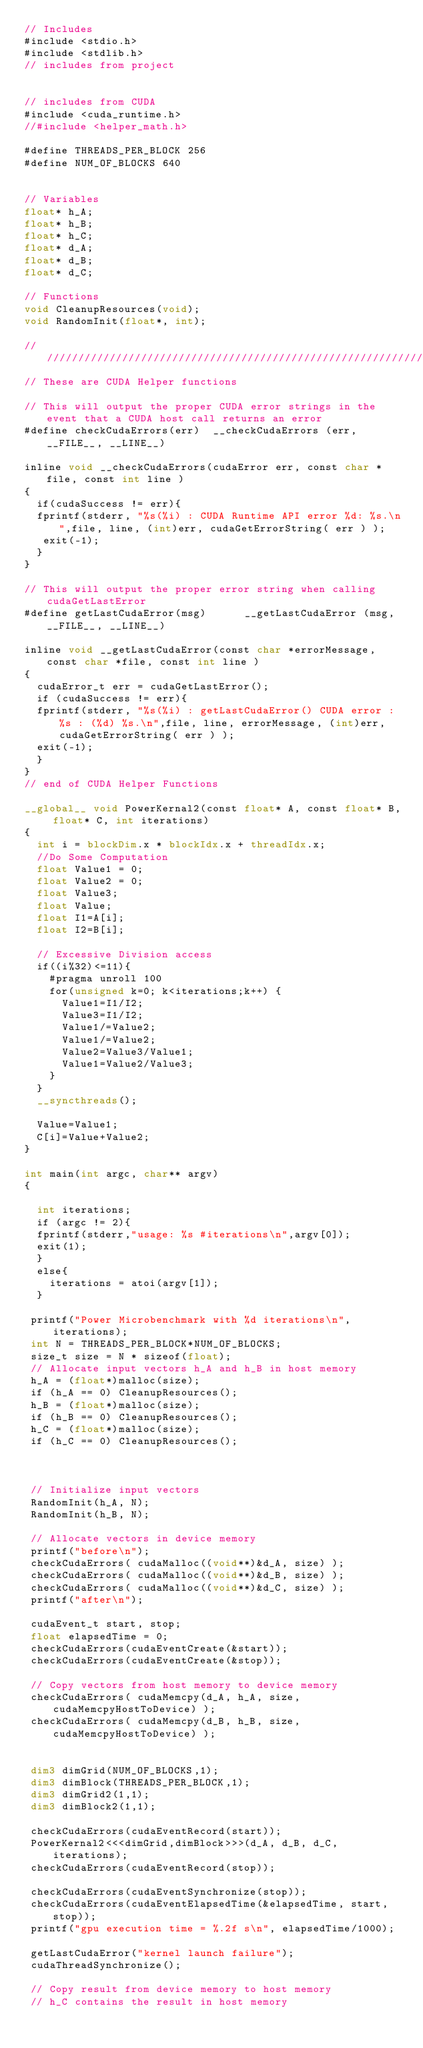Convert code to text. <code><loc_0><loc_0><loc_500><loc_500><_Cuda_>// Includes
#include <stdio.h>
#include <stdlib.h>
// includes from project


// includes from CUDA
#include <cuda_runtime.h>
//#include <helper_math.h>

#define THREADS_PER_BLOCK 256
#define NUM_OF_BLOCKS 640


// Variables
float* h_A;
float* h_B;
float* h_C;
float* d_A;
float* d_B;
float* d_C;

// Functions
void CleanupResources(void);
void RandomInit(float*, int);

////////////////////////////////////////////////////////////////////////////////
// These are CUDA Helper functions

// This will output the proper CUDA error strings in the event that a CUDA host call returns an error
#define checkCudaErrors(err)  __checkCudaErrors (err, __FILE__, __LINE__)

inline void __checkCudaErrors(cudaError err, const char *file, const int line )
{
  if(cudaSuccess != err){
  fprintf(stderr, "%s(%i) : CUDA Runtime API error %d: %s.\n",file, line, (int)err, cudaGetErrorString( err ) );
   exit(-1);
  }
}

// This will output the proper error string when calling cudaGetLastError
#define getLastCudaError(msg)      __getLastCudaError (msg, __FILE__, __LINE__)

inline void __getLastCudaError(const char *errorMessage, const char *file, const int line )
{
  cudaError_t err = cudaGetLastError();
  if (cudaSuccess != err){
  fprintf(stderr, "%s(%i) : getLastCudaError() CUDA error : %s : (%d) %s.\n",file, line, errorMessage, (int)err, cudaGetErrorString( err ) );
  exit(-1);
  }
}
// end of CUDA Helper Functions

__global__ void PowerKernal2(const float* A, const float* B, float* C, int iterations)
{
  int i = blockDim.x * blockIdx.x + threadIdx.x;
  //Do Some Computation
  float Value1 = 0;
  float Value2 = 0;
  float Value3;
  float Value;
  float I1=A[i];
  float I2=B[i];

  // Excessive Division access
  if((i%32)<=11){
    #pragma unroll 100
    for(unsigned k=0; k<iterations;k++) {
      Value1=I1/I2;
      Value3=I1/I2;
      Value1/=Value2;
      Value1/=Value2;
      Value2=Value3/Value1;
      Value1=Value2/Value3;
    }
  }
  __syncthreads();

  Value=Value1;
  C[i]=Value+Value2;
}

int main(int argc, char** argv) 
{

  int iterations;
  if (argc != 2){
  fprintf(stderr,"usage: %s #iterations\n",argv[0]);
  exit(1);
  }
  else{
    iterations = atoi(argv[1]);
  }

 printf("Power Microbenchmark with %d iterations\n",iterations);
 int N = THREADS_PER_BLOCK*NUM_OF_BLOCKS;
 size_t size = N * sizeof(float);
 // Allocate input vectors h_A and h_B in host memory
 h_A = (float*)malloc(size);
 if (h_A == 0) CleanupResources();
 h_B = (float*)malloc(size);
 if (h_B == 0) CleanupResources();
 h_C = (float*)malloc(size);
 if (h_C == 0) CleanupResources();



 // Initialize input vectors
 RandomInit(h_A, N);
 RandomInit(h_B, N);

 // Allocate vectors in device memory
 printf("before\n");
 checkCudaErrors( cudaMalloc((void**)&d_A, size) );
 checkCudaErrors( cudaMalloc((void**)&d_B, size) );
 checkCudaErrors( cudaMalloc((void**)&d_C, size) );
 printf("after\n");

 cudaEvent_t start, stop;
 float elapsedTime = 0;
 checkCudaErrors(cudaEventCreate(&start));
 checkCudaErrors(cudaEventCreate(&stop));

 // Copy vectors from host memory to device memory
 checkCudaErrors( cudaMemcpy(d_A, h_A, size, cudaMemcpyHostToDevice) );
 checkCudaErrors( cudaMemcpy(d_B, h_B, size, cudaMemcpyHostToDevice) );


 dim3 dimGrid(NUM_OF_BLOCKS,1);
 dim3 dimBlock(THREADS_PER_BLOCK,1);
 dim3 dimGrid2(1,1);
 dim3 dimBlock2(1,1);

 checkCudaErrors(cudaEventRecord(start));
 PowerKernal2<<<dimGrid,dimBlock>>>(d_A, d_B, d_C, iterations);
 checkCudaErrors(cudaEventRecord(stop));

 checkCudaErrors(cudaEventSynchronize(stop));
 checkCudaErrors(cudaEventElapsedTime(&elapsedTime, start, stop));
 printf("gpu execution time = %.2f s\n", elapsedTime/1000);

 getLastCudaError("kernel launch failure");
 cudaThreadSynchronize();

 // Copy result from device memory to host memory
 // h_C contains the result in host memory</code> 